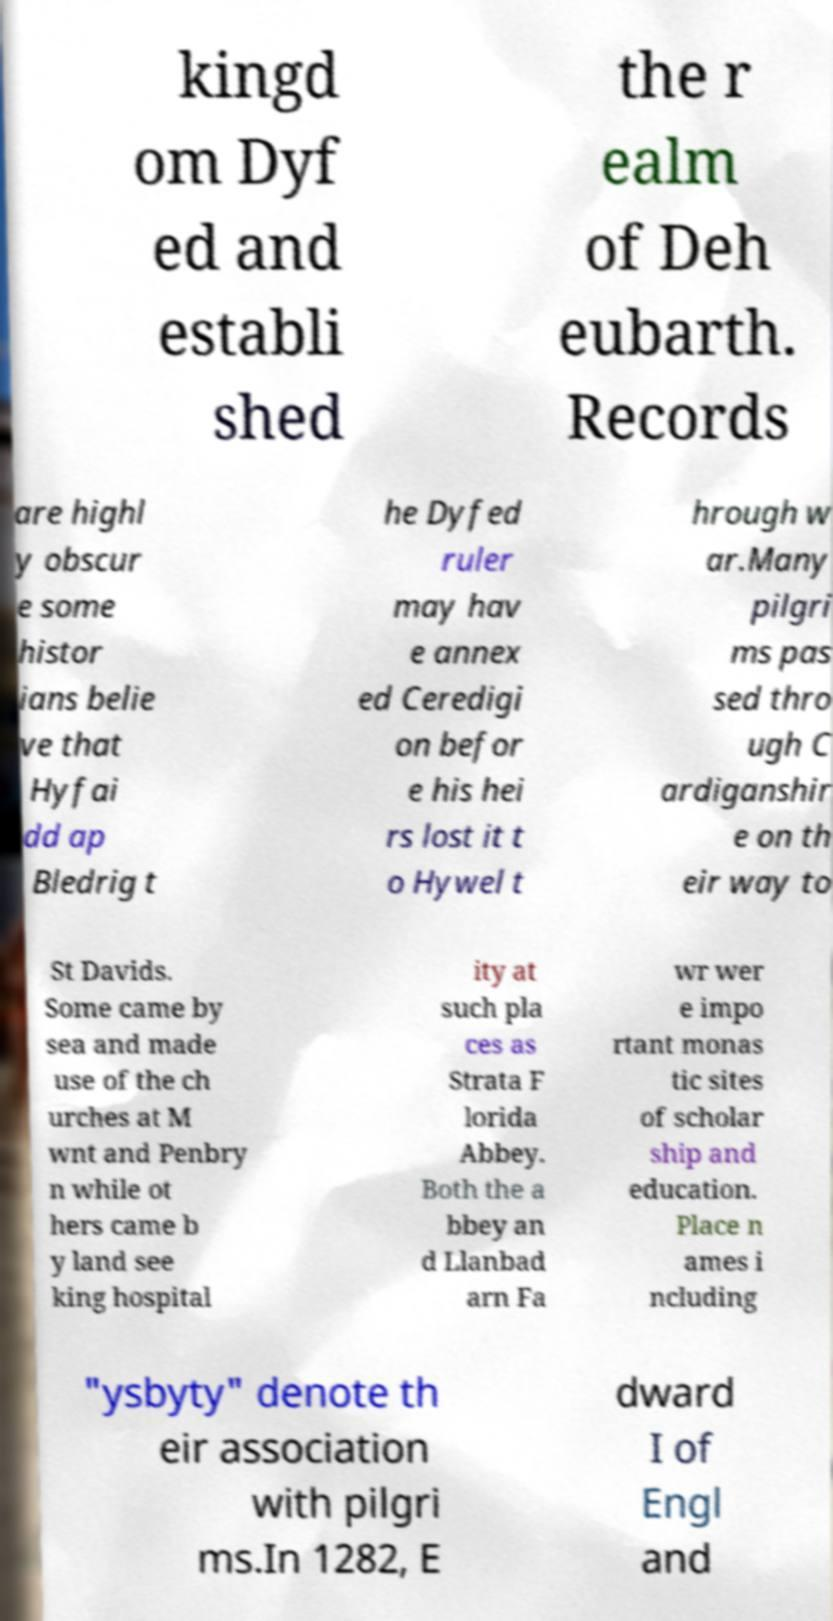Could you extract and type out the text from this image? kingd om Dyf ed and establi shed the r ealm of Deh eubarth. Records are highl y obscur e some histor ians belie ve that Hyfai dd ap Bledrig t he Dyfed ruler may hav e annex ed Ceredigi on befor e his hei rs lost it t o Hywel t hrough w ar.Many pilgri ms pas sed thro ugh C ardiganshir e on th eir way to St Davids. Some came by sea and made use of the ch urches at M wnt and Penbry n while ot hers came b y land see king hospital ity at such pla ces as Strata F lorida Abbey. Both the a bbey an d Llanbad arn Fa wr wer e impo rtant monas tic sites of scholar ship and education. Place n ames i ncluding "ysbyty" denote th eir association with pilgri ms.In 1282, E dward I of Engl and 